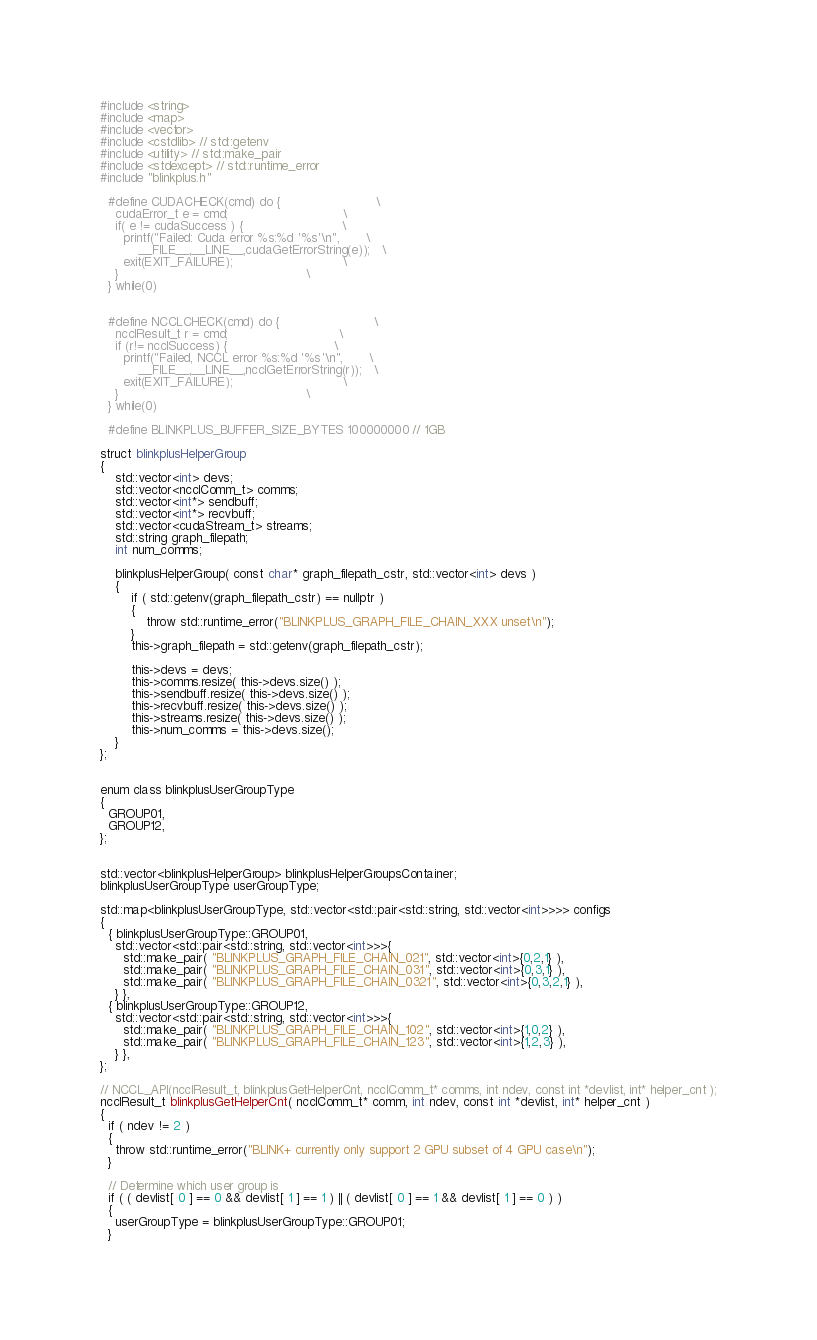Convert code to text. <code><loc_0><loc_0><loc_500><loc_500><_Cuda_>
#include <string>
#include <map>
#include <vector>
#include <cstdlib> // std::getenv
#include <utility> // std::make_pair
#include <stdexcept> // std::runtime_error
#include "blinkplus.h"

  #define CUDACHECK(cmd) do {                         \
    cudaError_t e = cmd;                              \
    if( e != cudaSuccess ) {                          \
      printf("Failed: Cuda error %s:%d '%s'\n",       \
          __FILE__,__LINE__,cudaGetErrorString(e));   \
      exit(EXIT_FAILURE);                             \
    }                                                 \
  } while(0)
  
  
  #define NCCLCHECK(cmd) do {                         \
    ncclResult_t r = cmd;                             \
    if (r!= ncclSuccess) {                            \
      printf("Failed, NCCL error %s:%d '%s'\n",       \
          __FILE__,__LINE__,ncclGetErrorString(r));   \
      exit(EXIT_FAILURE);                             \
    }                                                 \
  } while(0)

  #define BLINKPLUS_BUFFER_SIZE_BYTES 100000000 // 1GB

struct blinkplusHelperGroup
{
    std::vector<int> devs;
    std::vector<ncclComm_t> comms;
    std::vector<int*> sendbuff;
    std::vector<int*> recvbuff;
    std::vector<cudaStream_t> streams;
    std::string graph_filepath;
    int num_comms;

    blinkplusHelperGroup( const char* graph_filepath_cstr, std::vector<int> devs )
    {
        if ( std::getenv(graph_filepath_cstr) == nullptr )
        {
            throw std::runtime_error("BLINKPLUS_GRAPH_FILE_CHAIN_XXX unset\n");
        }
        this->graph_filepath = std::getenv(graph_filepath_cstr);

        this->devs = devs;
        this->comms.resize( this->devs.size() );
        this->sendbuff.resize( this->devs.size() );
        this->recvbuff.resize( this->devs.size() );
        this->streams.resize( this->devs.size() );
        this->num_comms = this->devs.size();
    }
};


enum class blinkplusUserGroupType
{
  GROUP01,
  GROUP12,
};


std::vector<blinkplusHelperGroup> blinkplusHelperGroupsContainer;
blinkplusUserGroupType userGroupType;

std::map<blinkplusUserGroupType, std::vector<std::pair<std::string, std::vector<int>>>> configs
{
  { blinkplusUserGroupType::GROUP01, 
    std::vector<std::pair<std::string, std::vector<int>>>{
      std::make_pair( "BLINKPLUS_GRAPH_FILE_CHAIN_021", std::vector<int>{0,2,1} ),
      std::make_pair( "BLINKPLUS_GRAPH_FILE_CHAIN_031", std::vector<int>{0,3,1} ),
      std::make_pair( "BLINKPLUS_GRAPH_FILE_CHAIN_0321", std::vector<int>{0,3,2,1} ),
    } },
  { blinkplusUserGroupType::GROUP12, 
    std::vector<std::pair<std::string, std::vector<int>>>{
      std::make_pair( "BLINKPLUS_GRAPH_FILE_CHAIN_102", std::vector<int>{1,0,2} ),
      std::make_pair( "BLINKPLUS_GRAPH_FILE_CHAIN_123", std::vector<int>{1,2,3} ),
    } },
};

// NCCL_API(ncclResult_t, blinkplusGetHelperCnt, ncclComm_t* comms, int ndev, const int *devlist, int* helper_cnt );
ncclResult_t blinkplusGetHelperCnt( ncclComm_t* comm, int ndev, const int *devlist, int* helper_cnt )
{
  if ( ndev != 2 )
  {
    throw std::runtime_error("BLINK+ currently only support 2 GPU subset of 4 GPU case\n");
  }

  // Determine which user group is
  if ( ( devlist[ 0 ] == 0 && devlist[ 1 ] == 1 ) || ( devlist[ 0 ] == 1 && devlist[ 1 ] == 0 ) )
  {
    userGroupType = blinkplusUserGroupType::GROUP01;
  }</code> 